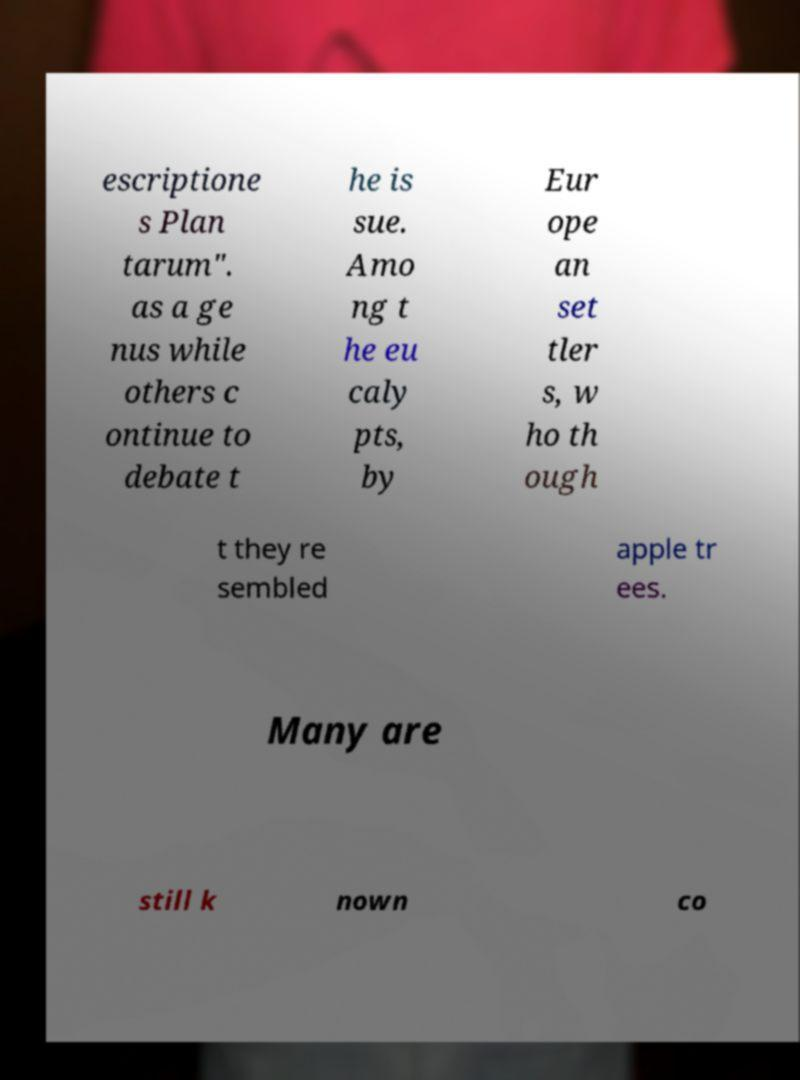For documentation purposes, I need the text within this image transcribed. Could you provide that? escriptione s Plan tarum". as a ge nus while others c ontinue to debate t he is sue. Amo ng t he eu caly pts, by Eur ope an set tler s, w ho th ough t they re sembled apple tr ees. Many are still k nown co 